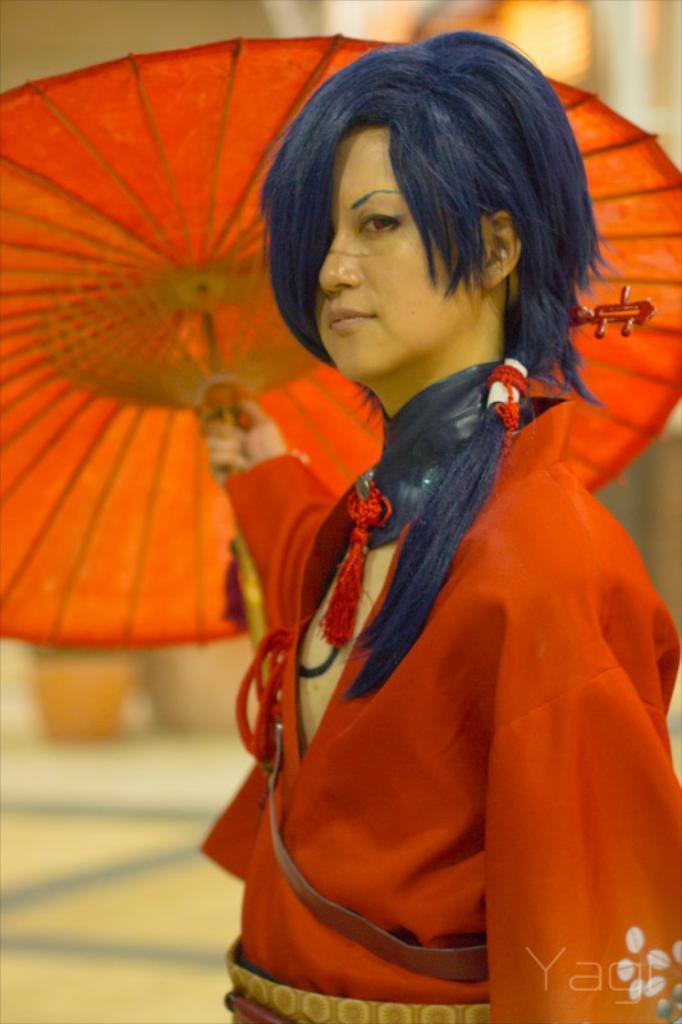In one or two sentences, can you explain what this image depicts? In the center of the image there is a woman holding an umbrella. 